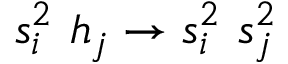<formula> <loc_0><loc_0><loc_500><loc_500>s _ { i } ^ { 2 } \ h _ { j } \to s _ { i } ^ { 2 } \ s _ { j } ^ { 2 }</formula> 